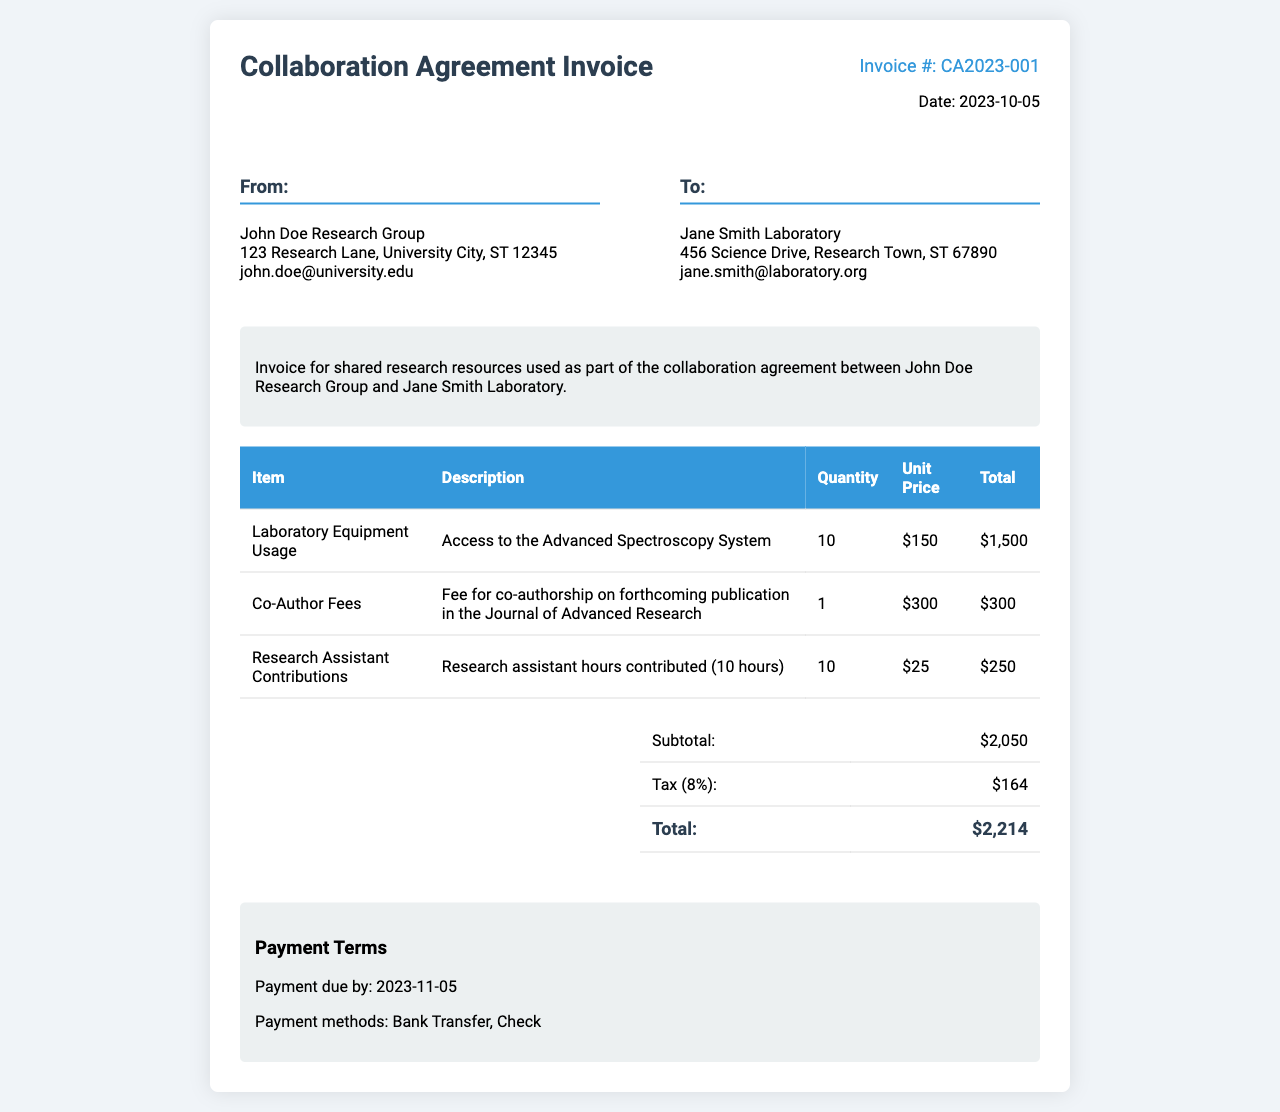What is the invoice number? The invoice number is a unique identifier for this invoice, found in the invoice details section.
Answer: CA2023-001 When is the payment due? The payment due date is specified in the payment terms section of the document.
Answer: 2023-11-05 What is the subtotal amount? The subtotal amount is calculated from the total of the listed items before tax, presented in the summary section.
Answer: $2,050 How many hours of research assistant contributions were billed? This information is provided in the item description for research assistant contributions, detailing the number of hours.
Answer: 10 What is the unit price for laboratory equipment usage? The unit price is specified next to the quantity for laboratory equipment usage in the invoice table.
Answer: $150 What is the tax rate applied to the subtotal? The tax rate can be inferred from the tax calculation shown in the summary table, often as a percentage.
Answer: 8% What is included in the description of the invoice? The description provides an overview of the reason for the invoice, summarizing its purpose.
Answer: Invoice for shared research resources used as part of the collaboration agreement What payment methods are accepted? The payment methods are listed in the payment terms section of the document.
Answer: Bank Transfer, Check What is the total amount due after tax? The total amount is provided in the summary section, established by adding the tax to the subtotal.
Answer: $2,214 